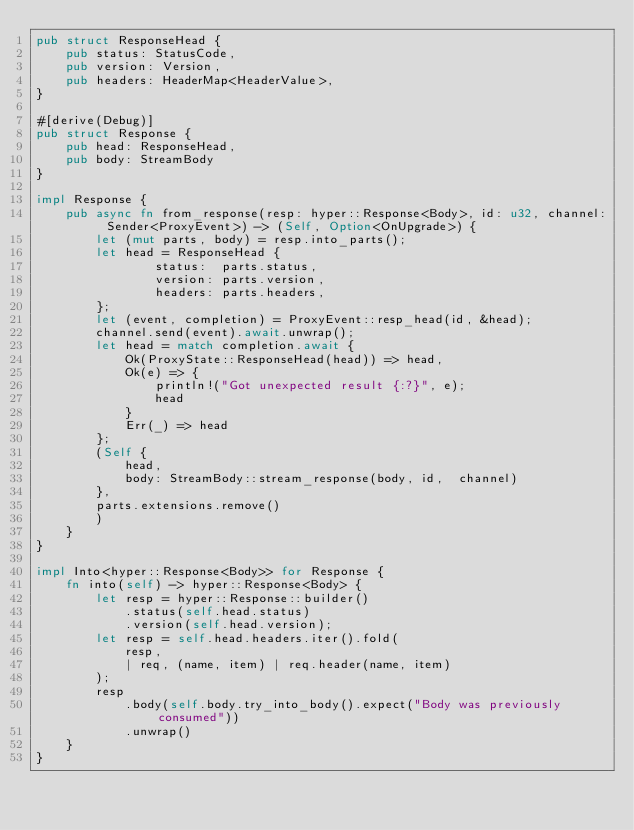Convert code to text. <code><loc_0><loc_0><loc_500><loc_500><_Rust_>pub struct ResponseHead {
    pub status: StatusCode,
    pub version: Version,
    pub headers: HeaderMap<HeaderValue>,
}

#[derive(Debug)]
pub struct Response {
    pub head: ResponseHead,
    pub body: StreamBody
}

impl Response {
    pub async fn from_response(resp: hyper::Response<Body>, id: u32, channel: Sender<ProxyEvent>) -> (Self, Option<OnUpgrade>) {
        let (mut parts, body) = resp.into_parts();
        let head = ResponseHead {
                status:  parts.status,
                version: parts.version,
                headers: parts.headers,
        };
        let (event, completion) = ProxyEvent::resp_head(id, &head);
        channel.send(event).await.unwrap();
        let head = match completion.await {
            Ok(ProxyState::ResponseHead(head)) => head,
            Ok(e) => {
                println!("Got unexpected result {:?}", e);
                head
            }
            Err(_) => head
        };
        (Self {
            head,
            body: StreamBody::stream_response(body, id,  channel)
        },
        parts.extensions.remove()
        )
    }
}

impl Into<hyper::Response<Body>> for Response {
    fn into(self) -> hyper::Response<Body> {
        let resp = hyper::Response::builder()
            .status(self.head.status)
            .version(self.head.version);
        let resp = self.head.headers.iter().fold(
            resp,
            | req, (name, item) | req.header(name, item)
        );
        resp
            .body(self.body.try_into_body().expect("Body was previously consumed"))
            .unwrap()
    }
}</code> 